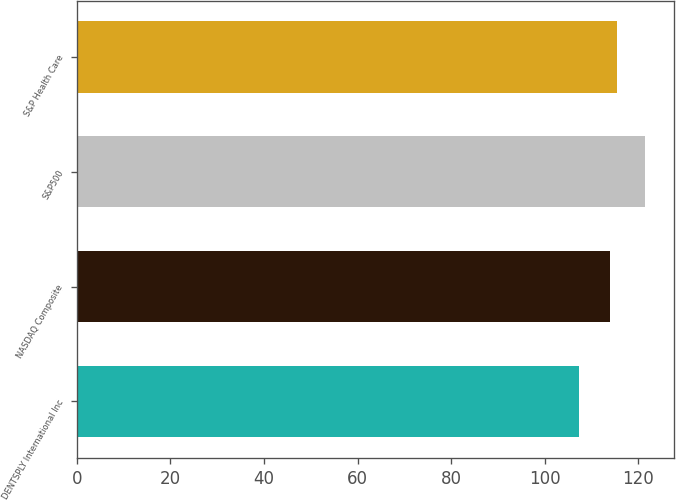<chart> <loc_0><loc_0><loc_500><loc_500><bar_chart><fcel>DENTSPLY International Inc<fcel>NASDAQ Composite<fcel>S&P500<fcel>S&P Health Care<nl><fcel>107.24<fcel>114.01<fcel>121.48<fcel>115.43<nl></chart> 